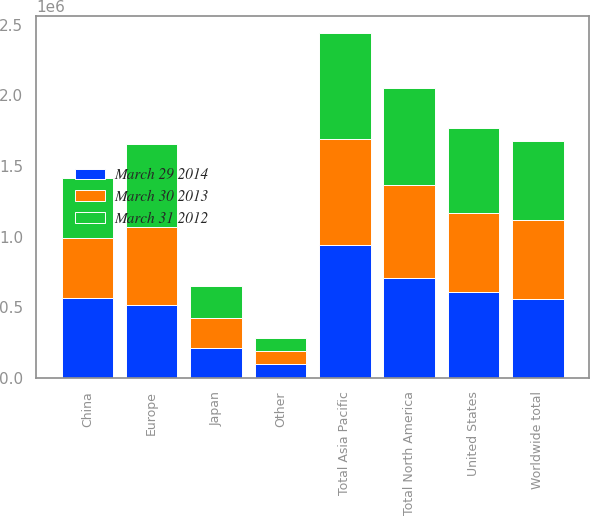Convert chart. <chart><loc_0><loc_0><loc_500><loc_500><stacked_bar_chart><ecel><fcel>United States<fcel>Other<fcel>Total North America<fcel>China<fcel>Total Asia Pacific<fcel>Europe<fcel>Japan<fcel>Worldwide total<nl><fcel>March 29 2014<fcel>610276<fcel>97416<fcel>707692<fcel>564814<fcel>939827<fcel>519829<fcel>215183<fcel>558309<nl><fcel>March 30 2013<fcel>558309<fcel>97251<fcel>655560<fcel>428892<fcel>753812<fcel>548375<fcel>210905<fcel>558309<nl><fcel>March 31 2012<fcel>596388<fcel>88037<fcel>684425<fcel>418036<fcel>744498<fcel>589802<fcel>222011<fcel>558309<nl></chart> 